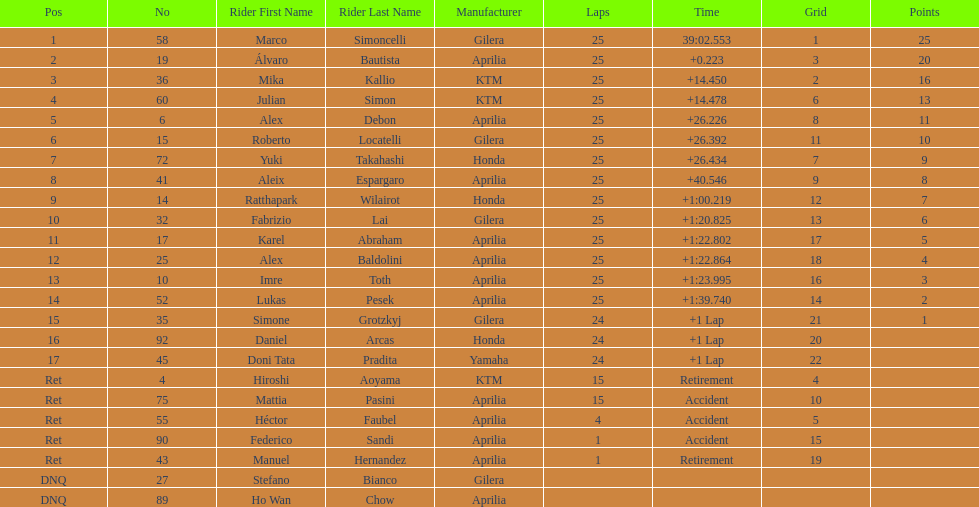The next rider from italy aside from winner marco simoncelli was Roberto Locatelli. 